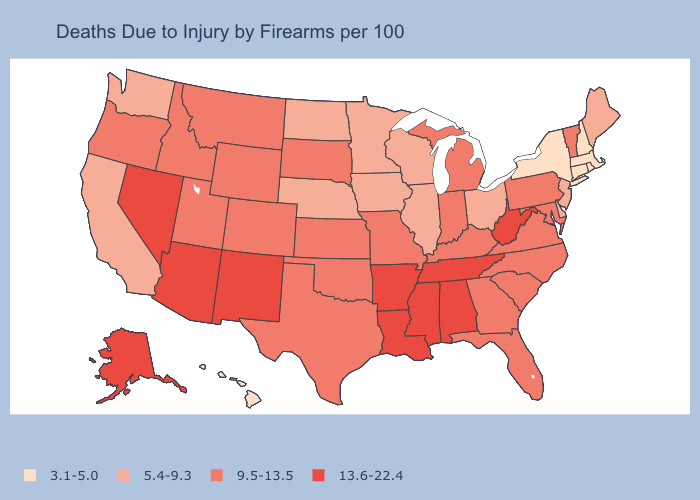What is the lowest value in the USA?
Quick response, please. 3.1-5.0. What is the highest value in the West ?
Keep it brief. 13.6-22.4. Among the states that border Oklahoma , does Colorado have the highest value?
Quick response, please. No. Name the states that have a value in the range 3.1-5.0?
Give a very brief answer. Connecticut, Hawaii, Massachusetts, New Hampshire, New York, Rhode Island. Among the states that border Ohio , does Michigan have the highest value?
Write a very short answer. No. What is the value of Michigan?
Answer briefly. 9.5-13.5. What is the highest value in the USA?
Be succinct. 13.6-22.4. Does Wisconsin have the same value as Iowa?
Quick response, please. Yes. What is the value of New Jersey?
Quick response, please. 5.4-9.3. Name the states that have a value in the range 5.4-9.3?
Write a very short answer. California, Delaware, Illinois, Iowa, Maine, Minnesota, Nebraska, New Jersey, North Dakota, Ohio, Washington, Wisconsin. Name the states that have a value in the range 9.5-13.5?
Quick response, please. Colorado, Florida, Georgia, Idaho, Indiana, Kansas, Kentucky, Maryland, Michigan, Missouri, Montana, North Carolina, Oklahoma, Oregon, Pennsylvania, South Carolina, South Dakota, Texas, Utah, Vermont, Virginia, Wyoming. Does New York have the lowest value in the USA?
Short answer required. Yes. What is the value of Hawaii?
Short answer required. 3.1-5.0. What is the lowest value in states that border Michigan?
Short answer required. 5.4-9.3. Which states have the lowest value in the USA?
Keep it brief. Connecticut, Hawaii, Massachusetts, New Hampshire, New York, Rhode Island. 